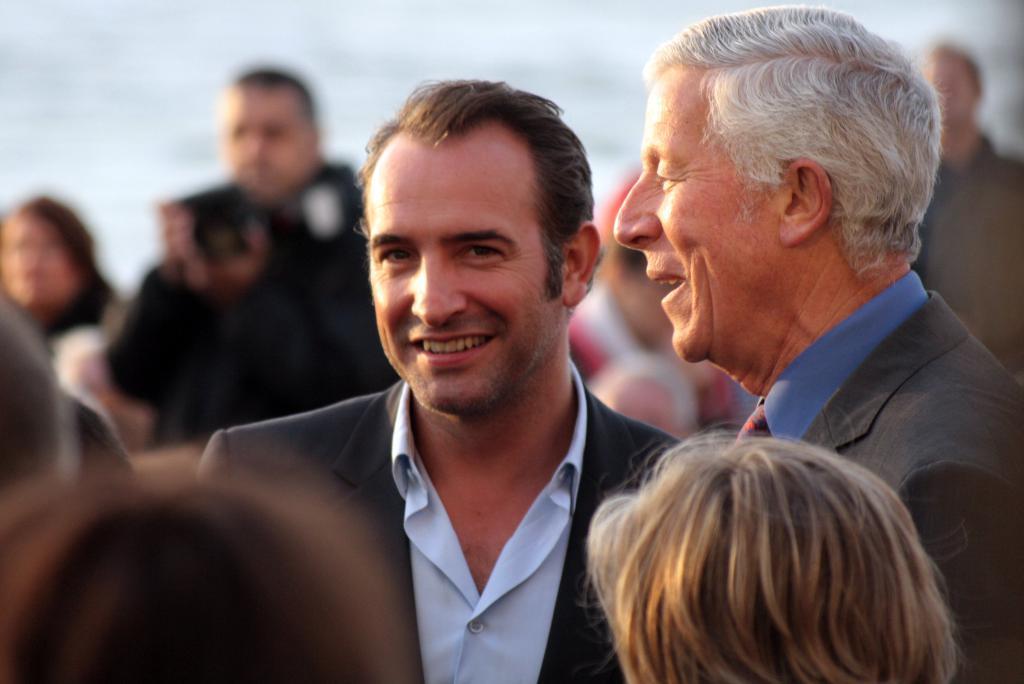In one or two sentences, can you explain what this image depicts? In the picture we can see some people are standing and two people are smiling, they are in blazers and shirts and behind we can see a man standing and holding a camera. 